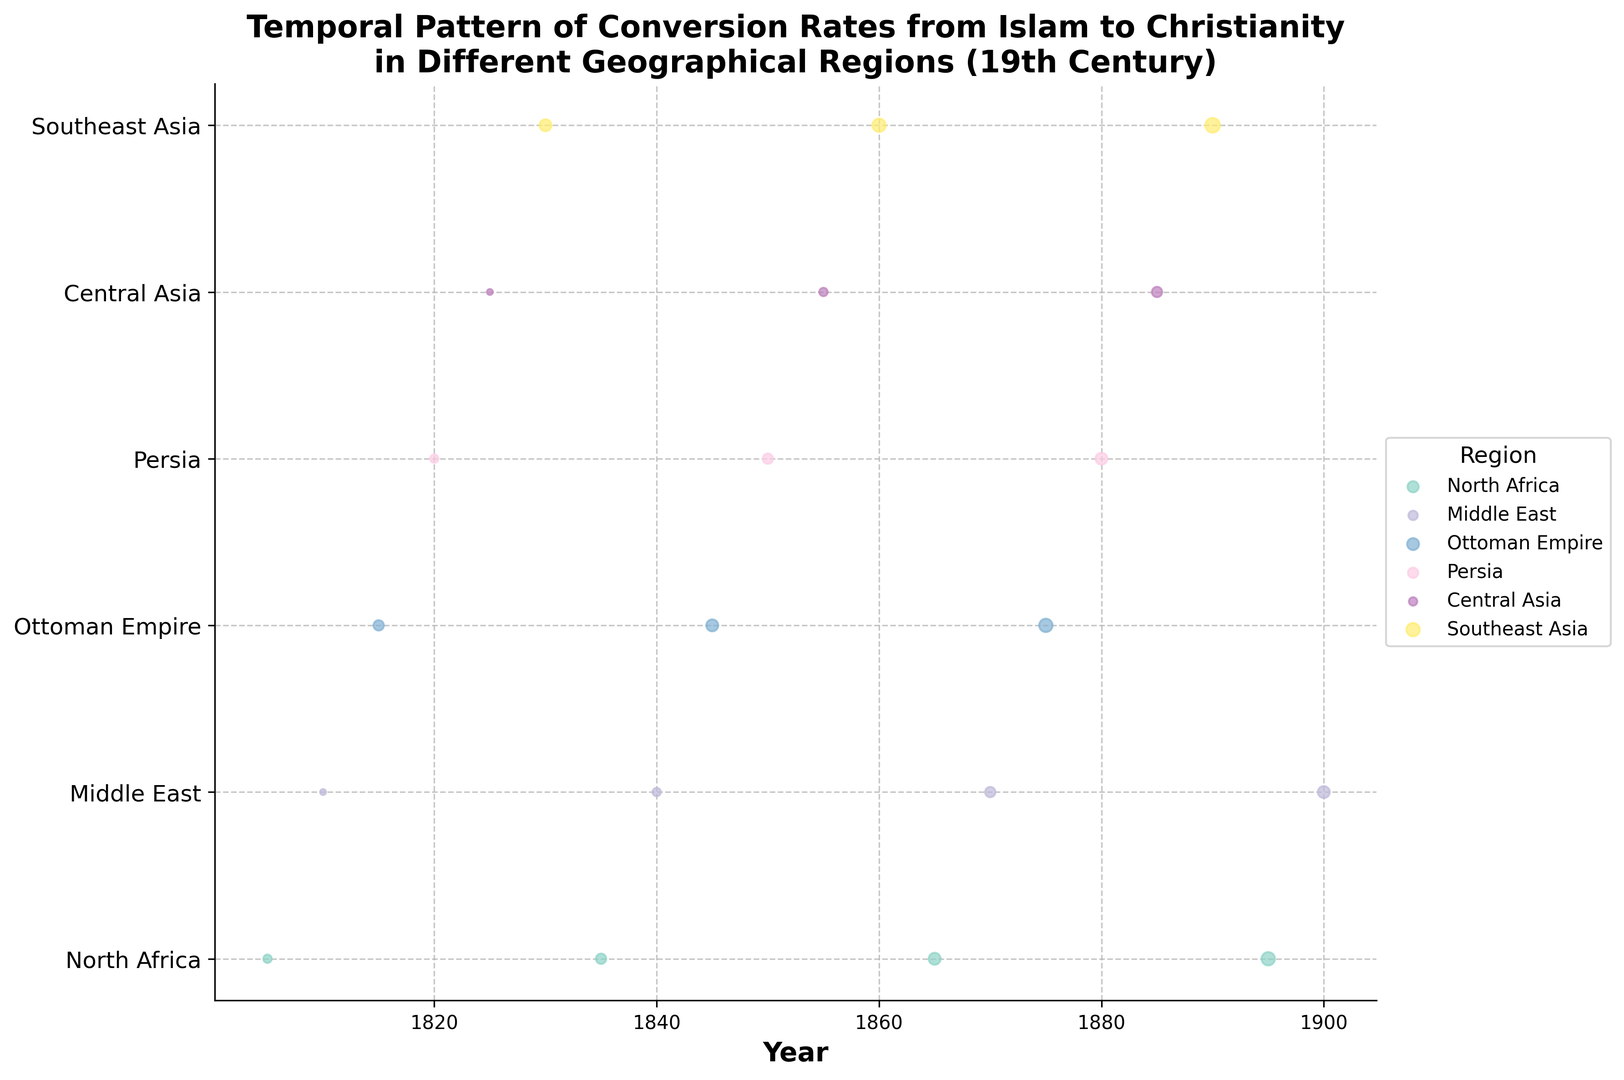Which region experienced the highest conversion rate in 1890? By looking at the data points for the year 1890, identify the region with the largest size of the scatter point, which represents the highest conversion rate. In this case, Southeast Asia has the largest scatter point in 1890.
Answer: Southeast Asia Which decade showed the highest conversion rate in North Africa? Review the scatter points for North Africa across the 19th century. Compare the sizes and identify the decade with the largest scatter point (indicating the highest conversion rate). Here, the largest scatter point for North Africa is in 1895.
Answer: 1890s What is the average conversion rate in the Middle East across the 19th century? To find the average, extract the conversion rates of the Middle East from the data and then calculate the mean: (0.01 + 0.02 + 0.03 + 0.04) / 4.
Answer: 0.025 Compare the conversion rate trends in the Ottoman Empire and Persia. Which region shows a quicker increase in conversion rate over time? Analyze the scatter points for both the Ottoman Empire and Persia. Compare their conversion rate increases from the beginning to the end of the 19th century. The Ottoman Empire shows a quicker increase from 0.03 to 0.05, whereas Persia increases from 0.02 to 0.04.
Answer: Ottoman Empire How did the conversion rate in Central Asia change from 1825 to 1885? Look at the scatter points for Central Asia in 1825 and 1885. Calculate the difference: 0.03 (1885) - 0.01 (1825). Thus, the conversion rate increased by 0.02.
Answer: Increased by 0.02 Which region had a conversion rate of 0.05 in the late 19th century, and what year was it? Examine the scatter points to find those that represent a conversion rate of 0.05 in the late 19th century. Central Asia had a rate of 0.05 in the year 1890.
Answer: Central Asia, 1890 How does the conversion rate in Southeast Asia in 1890 compare to that in 1860? Identify the scatter points for Southeast Asia in 1860 and 1890 and compare their sizes: 0.06 (1890) and 0.05 (1860). The conversion rate increased.
Answer: Increased In which year did the Ottoman Empire have its highest recorded conversion rate, and what was the rate? Find the largest scatter point for the Ottoman Empire and note the corresponding year and rate. The highest rate was 0.05 in 1875.
Answer: 1875, 0.05 What's the combined conversion rate for Central Asia in 1825 and 1885? Sum the rates for Central Asia in 1825 and 1885: 0.01 + 0.03.
Answer: 0.04 Which geographical region showed no change in conversion rates between its earliest and latest observed years? Compare each region's earliest and latest conversion rates. If they are equal, then there was no change. None of the regions have the same conversion rate at the start and end of the 19th century.
Answer: None 